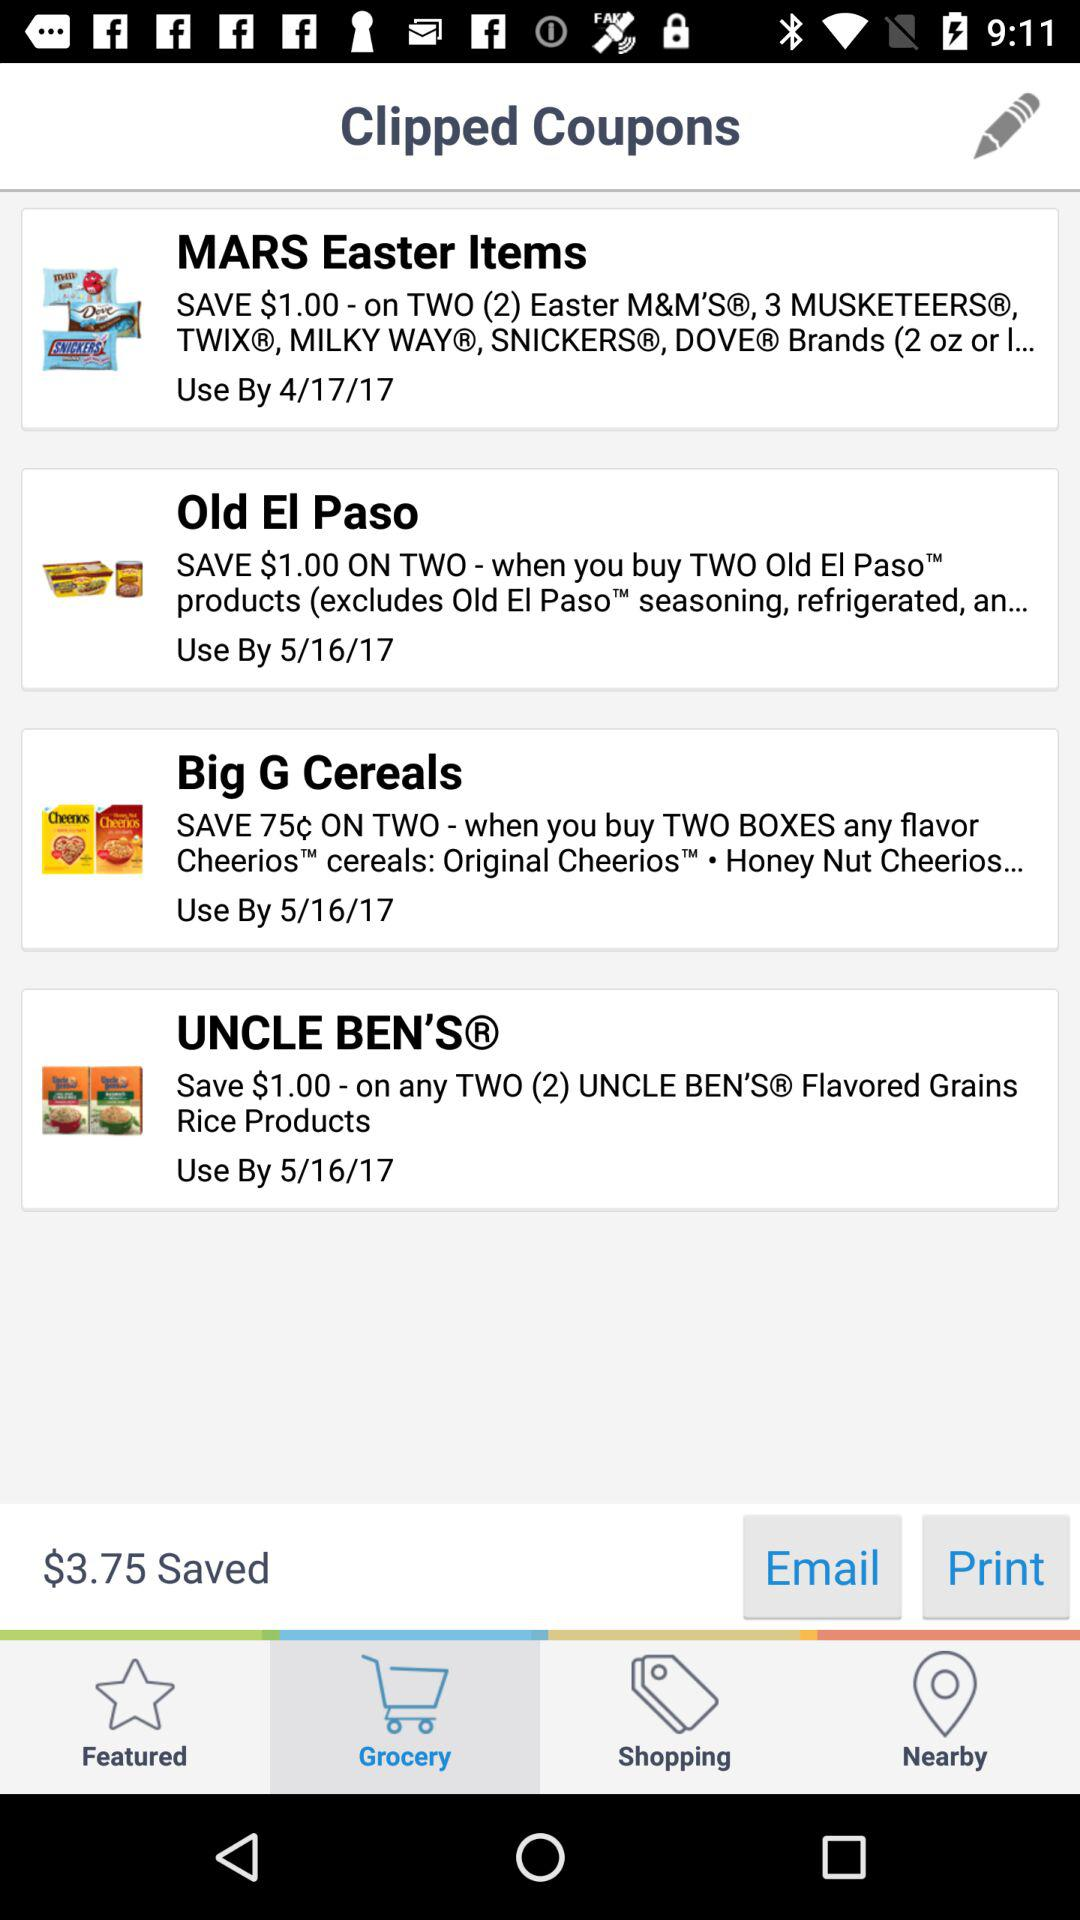How much money is saved by clipping these coupons?
Answer the question using a single word or phrase. $3.75 